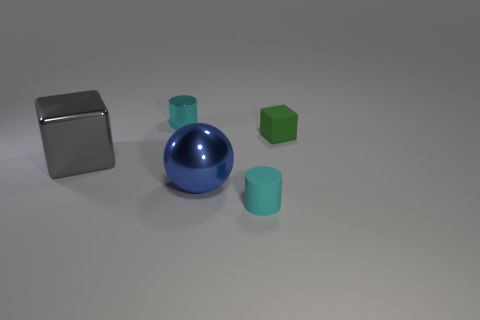Are there any other things that have the same size as the gray metallic object?
Offer a terse response. Yes. What color is the large block that is the same material as the blue thing?
Give a very brief answer. Gray. How many blocks are either gray things or cyan shiny things?
Provide a succinct answer. 1. How many things are tiny things or metal things that are to the left of the large blue object?
Make the answer very short. 4. Are there any large matte cylinders?
Your answer should be very brief. No. What number of small cylinders have the same color as the small cube?
Make the answer very short. 0. There is another small cylinder that is the same color as the tiny rubber cylinder; what is it made of?
Provide a short and direct response. Metal. What size is the cube on the left side of the cyan cylinder to the left of the large blue thing?
Your answer should be very brief. Large. Are there any small cubes made of the same material as the gray object?
Ensure brevity in your answer.  No. There is a ball that is the same size as the metallic cube; what is its material?
Provide a short and direct response. Metal. 